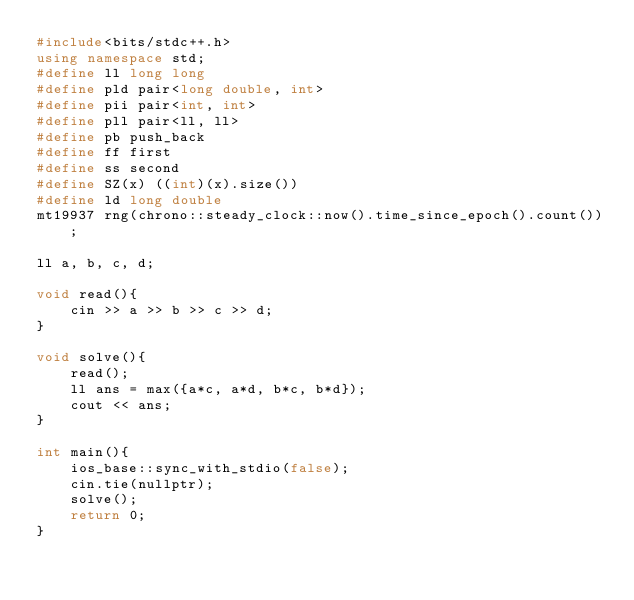Convert code to text. <code><loc_0><loc_0><loc_500><loc_500><_C++_>#include<bits/stdc++.h>
using namespace std;
#define ll long long
#define pld pair<long double, int>
#define pii pair<int, int>
#define pll pair<ll, ll>
#define pb push_back
#define ff first
#define ss second
#define SZ(x) ((int)(x).size())
#define ld long double
mt19937 rng(chrono::steady_clock::now().time_since_epoch().count());

ll a, b, c, d;

void read(){
    cin >> a >> b >> c >> d;
}

void solve(){
    read();
    ll ans = max({a*c, a*d, b*c, b*d});
    cout << ans;
}

int main(){
    ios_base::sync_with_stdio(false);
    cin.tie(nullptr);
    solve();
    return 0;
}</code> 